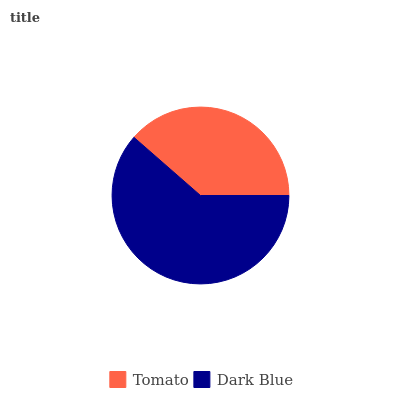Is Tomato the minimum?
Answer yes or no. Yes. Is Dark Blue the maximum?
Answer yes or no. Yes. Is Dark Blue the minimum?
Answer yes or no. No. Is Dark Blue greater than Tomato?
Answer yes or no. Yes. Is Tomato less than Dark Blue?
Answer yes or no. Yes. Is Tomato greater than Dark Blue?
Answer yes or no. No. Is Dark Blue less than Tomato?
Answer yes or no. No. Is Dark Blue the high median?
Answer yes or no. Yes. Is Tomato the low median?
Answer yes or no. Yes. Is Tomato the high median?
Answer yes or no. No. Is Dark Blue the low median?
Answer yes or no. No. 